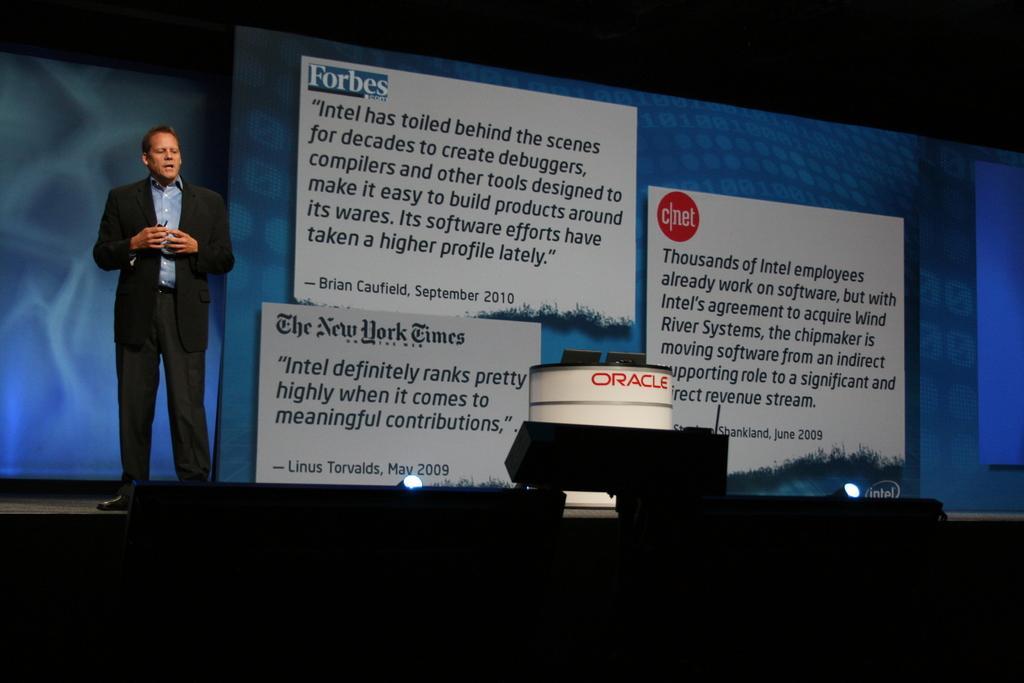Please provide a concise description of this image. In this image I can see a person standing on the left, wearing a suit. There is a display screen at the back and there are lights at the bottom. 